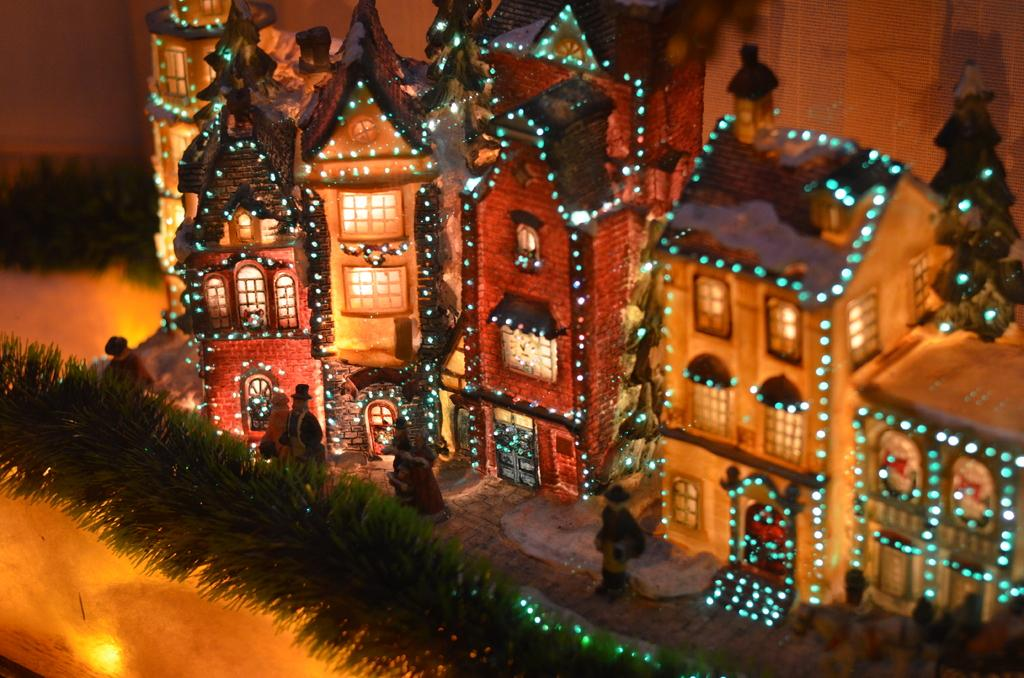What is the main subject of the image? There is a miniature in the image. Are there any people present in the image? Yes, there are people standing in the image. What can be seen in the background of the image? There is a building in the background of the image. How is the building decorated? The building is decorated with lights. Can you see any icicles hanging from the building in the image? There is no mention of icicles in the provided facts, so we cannot determine if any are present in the image. Is there a flock of birds nesting on the building in the image? There is no mention of birds or nests in the provided facts, so we cannot determine if any are present in the image. 